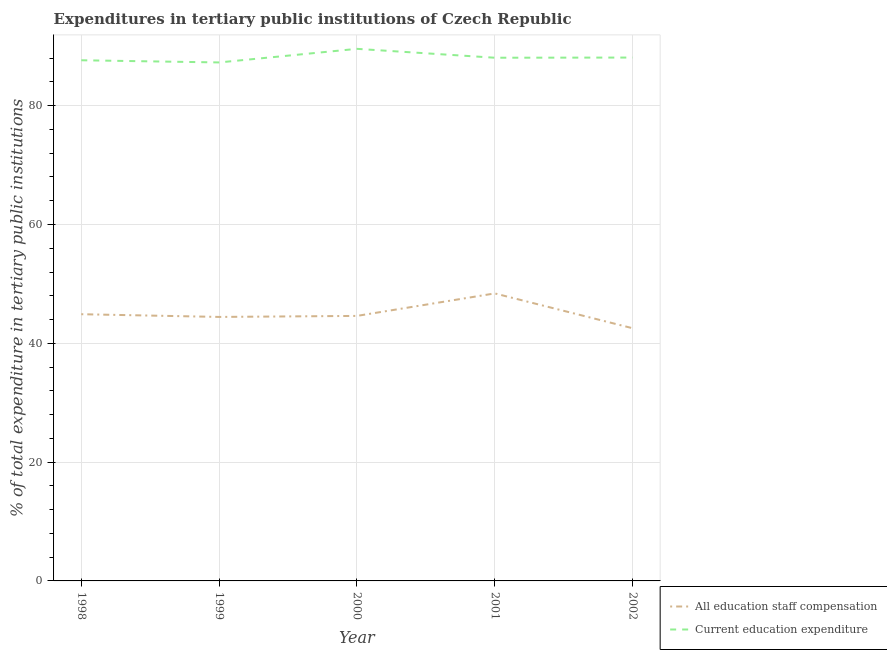How many different coloured lines are there?
Your answer should be very brief. 2. Does the line corresponding to expenditure in staff compensation intersect with the line corresponding to expenditure in education?
Give a very brief answer. No. Is the number of lines equal to the number of legend labels?
Provide a succinct answer. Yes. What is the expenditure in education in 1999?
Keep it short and to the point. 87.28. Across all years, what is the maximum expenditure in staff compensation?
Your answer should be compact. 48.4. Across all years, what is the minimum expenditure in staff compensation?
Keep it short and to the point. 42.54. What is the total expenditure in education in the graph?
Provide a short and direct response. 440.67. What is the difference between the expenditure in education in 1998 and that in 2001?
Provide a succinct answer. -0.43. What is the difference between the expenditure in staff compensation in 1998 and the expenditure in education in 2000?
Your answer should be very brief. -44.67. What is the average expenditure in staff compensation per year?
Ensure brevity in your answer.  44.98. In the year 2000, what is the difference between the expenditure in education and expenditure in staff compensation?
Offer a very short reply. 44.96. What is the ratio of the expenditure in staff compensation in 2001 to that in 2002?
Give a very brief answer. 1.14. What is the difference between the highest and the second highest expenditure in staff compensation?
Provide a short and direct response. 3.5. What is the difference between the highest and the lowest expenditure in education?
Keep it short and to the point. 2.29. In how many years, is the expenditure in education greater than the average expenditure in education taken over all years?
Your response must be concise. 1. Is the expenditure in education strictly greater than the expenditure in staff compensation over the years?
Give a very brief answer. Yes. Is the expenditure in staff compensation strictly less than the expenditure in education over the years?
Offer a terse response. Yes. What is the difference between two consecutive major ticks on the Y-axis?
Offer a terse response. 20. Does the graph contain grids?
Give a very brief answer. Yes. How many legend labels are there?
Provide a short and direct response. 2. What is the title of the graph?
Your response must be concise. Expenditures in tertiary public institutions of Czech Republic. What is the label or title of the Y-axis?
Your answer should be very brief. % of total expenditure in tertiary public institutions. What is the % of total expenditure in tertiary public institutions in All education staff compensation in 1998?
Your answer should be very brief. 44.9. What is the % of total expenditure in tertiary public institutions of Current education expenditure in 1998?
Provide a succinct answer. 87.65. What is the % of total expenditure in tertiary public institutions in All education staff compensation in 1999?
Your response must be concise. 44.44. What is the % of total expenditure in tertiary public institutions of Current education expenditure in 1999?
Ensure brevity in your answer.  87.28. What is the % of total expenditure in tertiary public institutions in All education staff compensation in 2000?
Make the answer very short. 44.61. What is the % of total expenditure in tertiary public institutions in Current education expenditure in 2000?
Give a very brief answer. 89.57. What is the % of total expenditure in tertiary public institutions in All education staff compensation in 2001?
Your answer should be very brief. 48.4. What is the % of total expenditure in tertiary public institutions in Current education expenditure in 2001?
Provide a short and direct response. 88.07. What is the % of total expenditure in tertiary public institutions of All education staff compensation in 2002?
Provide a short and direct response. 42.54. What is the % of total expenditure in tertiary public institutions in Current education expenditure in 2002?
Make the answer very short. 88.1. Across all years, what is the maximum % of total expenditure in tertiary public institutions of All education staff compensation?
Make the answer very short. 48.4. Across all years, what is the maximum % of total expenditure in tertiary public institutions of Current education expenditure?
Offer a terse response. 89.57. Across all years, what is the minimum % of total expenditure in tertiary public institutions in All education staff compensation?
Offer a very short reply. 42.54. Across all years, what is the minimum % of total expenditure in tertiary public institutions of Current education expenditure?
Ensure brevity in your answer.  87.28. What is the total % of total expenditure in tertiary public institutions in All education staff compensation in the graph?
Ensure brevity in your answer.  224.88. What is the total % of total expenditure in tertiary public institutions in Current education expenditure in the graph?
Provide a short and direct response. 440.67. What is the difference between the % of total expenditure in tertiary public institutions of All education staff compensation in 1998 and that in 1999?
Give a very brief answer. 0.46. What is the difference between the % of total expenditure in tertiary public institutions of Current education expenditure in 1998 and that in 1999?
Offer a terse response. 0.37. What is the difference between the % of total expenditure in tertiary public institutions of All education staff compensation in 1998 and that in 2000?
Ensure brevity in your answer.  0.28. What is the difference between the % of total expenditure in tertiary public institutions in Current education expenditure in 1998 and that in 2000?
Your answer should be compact. -1.92. What is the difference between the % of total expenditure in tertiary public institutions in All education staff compensation in 1998 and that in 2001?
Keep it short and to the point. -3.5. What is the difference between the % of total expenditure in tertiary public institutions in Current education expenditure in 1998 and that in 2001?
Provide a succinct answer. -0.43. What is the difference between the % of total expenditure in tertiary public institutions of All education staff compensation in 1998 and that in 2002?
Offer a terse response. 2.36. What is the difference between the % of total expenditure in tertiary public institutions in Current education expenditure in 1998 and that in 2002?
Provide a short and direct response. -0.46. What is the difference between the % of total expenditure in tertiary public institutions in All education staff compensation in 1999 and that in 2000?
Give a very brief answer. -0.17. What is the difference between the % of total expenditure in tertiary public institutions in Current education expenditure in 1999 and that in 2000?
Give a very brief answer. -2.29. What is the difference between the % of total expenditure in tertiary public institutions in All education staff compensation in 1999 and that in 2001?
Your answer should be compact. -3.96. What is the difference between the % of total expenditure in tertiary public institutions of Current education expenditure in 1999 and that in 2001?
Offer a terse response. -0.79. What is the difference between the % of total expenditure in tertiary public institutions in All education staff compensation in 1999 and that in 2002?
Make the answer very short. 1.9. What is the difference between the % of total expenditure in tertiary public institutions in Current education expenditure in 1999 and that in 2002?
Keep it short and to the point. -0.82. What is the difference between the % of total expenditure in tertiary public institutions in All education staff compensation in 2000 and that in 2001?
Keep it short and to the point. -3.79. What is the difference between the % of total expenditure in tertiary public institutions of Current education expenditure in 2000 and that in 2001?
Ensure brevity in your answer.  1.5. What is the difference between the % of total expenditure in tertiary public institutions in All education staff compensation in 2000 and that in 2002?
Keep it short and to the point. 2.07. What is the difference between the % of total expenditure in tertiary public institutions of Current education expenditure in 2000 and that in 2002?
Give a very brief answer. 1.47. What is the difference between the % of total expenditure in tertiary public institutions in All education staff compensation in 2001 and that in 2002?
Make the answer very short. 5.86. What is the difference between the % of total expenditure in tertiary public institutions of Current education expenditure in 2001 and that in 2002?
Your answer should be very brief. -0.03. What is the difference between the % of total expenditure in tertiary public institutions in All education staff compensation in 1998 and the % of total expenditure in tertiary public institutions in Current education expenditure in 1999?
Give a very brief answer. -42.38. What is the difference between the % of total expenditure in tertiary public institutions of All education staff compensation in 1998 and the % of total expenditure in tertiary public institutions of Current education expenditure in 2000?
Make the answer very short. -44.67. What is the difference between the % of total expenditure in tertiary public institutions in All education staff compensation in 1998 and the % of total expenditure in tertiary public institutions in Current education expenditure in 2001?
Make the answer very short. -43.18. What is the difference between the % of total expenditure in tertiary public institutions of All education staff compensation in 1998 and the % of total expenditure in tertiary public institutions of Current education expenditure in 2002?
Offer a very short reply. -43.21. What is the difference between the % of total expenditure in tertiary public institutions in All education staff compensation in 1999 and the % of total expenditure in tertiary public institutions in Current education expenditure in 2000?
Ensure brevity in your answer.  -45.13. What is the difference between the % of total expenditure in tertiary public institutions of All education staff compensation in 1999 and the % of total expenditure in tertiary public institutions of Current education expenditure in 2001?
Ensure brevity in your answer.  -43.63. What is the difference between the % of total expenditure in tertiary public institutions in All education staff compensation in 1999 and the % of total expenditure in tertiary public institutions in Current education expenditure in 2002?
Your answer should be very brief. -43.66. What is the difference between the % of total expenditure in tertiary public institutions of All education staff compensation in 2000 and the % of total expenditure in tertiary public institutions of Current education expenditure in 2001?
Give a very brief answer. -43.46. What is the difference between the % of total expenditure in tertiary public institutions in All education staff compensation in 2000 and the % of total expenditure in tertiary public institutions in Current education expenditure in 2002?
Your response must be concise. -43.49. What is the difference between the % of total expenditure in tertiary public institutions in All education staff compensation in 2001 and the % of total expenditure in tertiary public institutions in Current education expenditure in 2002?
Provide a short and direct response. -39.7. What is the average % of total expenditure in tertiary public institutions of All education staff compensation per year?
Your answer should be compact. 44.98. What is the average % of total expenditure in tertiary public institutions in Current education expenditure per year?
Provide a succinct answer. 88.13. In the year 1998, what is the difference between the % of total expenditure in tertiary public institutions in All education staff compensation and % of total expenditure in tertiary public institutions in Current education expenditure?
Provide a succinct answer. -42.75. In the year 1999, what is the difference between the % of total expenditure in tertiary public institutions in All education staff compensation and % of total expenditure in tertiary public institutions in Current education expenditure?
Keep it short and to the point. -42.84. In the year 2000, what is the difference between the % of total expenditure in tertiary public institutions of All education staff compensation and % of total expenditure in tertiary public institutions of Current education expenditure?
Offer a terse response. -44.96. In the year 2001, what is the difference between the % of total expenditure in tertiary public institutions in All education staff compensation and % of total expenditure in tertiary public institutions in Current education expenditure?
Your answer should be compact. -39.67. In the year 2002, what is the difference between the % of total expenditure in tertiary public institutions in All education staff compensation and % of total expenditure in tertiary public institutions in Current education expenditure?
Offer a very short reply. -45.57. What is the ratio of the % of total expenditure in tertiary public institutions in All education staff compensation in 1998 to that in 1999?
Keep it short and to the point. 1.01. What is the ratio of the % of total expenditure in tertiary public institutions in Current education expenditure in 1998 to that in 1999?
Your answer should be compact. 1. What is the ratio of the % of total expenditure in tertiary public institutions in All education staff compensation in 1998 to that in 2000?
Ensure brevity in your answer.  1.01. What is the ratio of the % of total expenditure in tertiary public institutions in Current education expenditure in 1998 to that in 2000?
Provide a succinct answer. 0.98. What is the ratio of the % of total expenditure in tertiary public institutions in All education staff compensation in 1998 to that in 2001?
Your response must be concise. 0.93. What is the ratio of the % of total expenditure in tertiary public institutions in All education staff compensation in 1998 to that in 2002?
Give a very brief answer. 1.06. What is the ratio of the % of total expenditure in tertiary public institutions in Current education expenditure in 1998 to that in 2002?
Offer a very short reply. 0.99. What is the ratio of the % of total expenditure in tertiary public institutions of Current education expenditure in 1999 to that in 2000?
Provide a short and direct response. 0.97. What is the ratio of the % of total expenditure in tertiary public institutions in All education staff compensation in 1999 to that in 2001?
Your answer should be compact. 0.92. What is the ratio of the % of total expenditure in tertiary public institutions in Current education expenditure in 1999 to that in 2001?
Provide a short and direct response. 0.99. What is the ratio of the % of total expenditure in tertiary public institutions of All education staff compensation in 1999 to that in 2002?
Make the answer very short. 1.04. What is the ratio of the % of total expenditure in tertiary public institutions of All education staff compensation in 2000 to that in 2001?
Your response must be concise. 0.92. What is the ratio of the % of total expenditure in tertiary public institutions in Current education expenditure in 2000 to that in 2001?
Your answer should be very brief. 1.02. What is the ratio of the % of total expenditure in tertiary public institutions of All education staff compensation in 2000 to that in 2002?
Give a very brief answer. 1.05. What is the ratio of the % of total expenditure in tertiary public institutions of Current education expenditure in 2000 to that in 2002?
Your answer should be compact. 1.02. What is the ratio of the % of total expenditure in tertiary public institutions in All education staff compensation in 2001 to that in 2002?
Your response must be concise. 1.14. What is the ratio of the % of total expenditure in tertiary public institutions of Current education expenditure in 2001 to that in 2002?
Make the answer very short. 1. What is the difference between the highest and the second highest % of total expenditure in tertiary public institutions of All education staff compensation?
Offer a very short reply. 3.5. What is the difference between the highest and the second highest % of total expenditure in tertiary public institutions in Current education expenditure?
Offer a very short reply. 1.47. What is the difference between the highest and the lowest % of total expenditure in tertiary public institutions in All education staff compensation?
Provide a succinct answer. 5.86. What is the difference between the highest and the lowest % of total expenditure in tertiary public institutions of Current education expenditure?
Give a very brief answer. 2.29. 